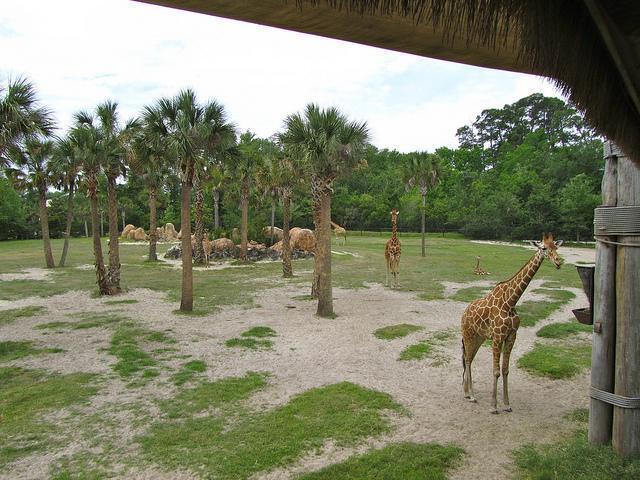How many bodies of water present?
Give a very brief answer. 0. How many animals can be seen?
Give a very brief answer. 3. 